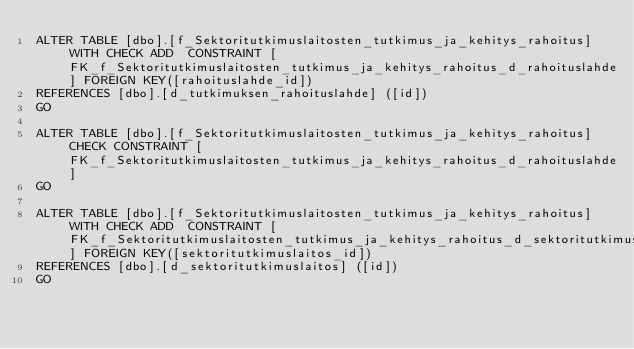Convert code to text. <code><loc_0><loc_0><loc_500><loc_500><_SQL_>ALTER TABLE [dbo].[f_Sektoritutkimuslaitosten_tutkimus_ja_kehitys_rahoitus]  WITH CHECK ADD  CONSTRAINT [FK_f_Sektoritutkimuslaitosten_tutkimus_ja_kehitys_rahoitus_d_rahoituslahde] FOREIGN KEY([rahoituslahde_id])
REFERENCES [dbo].[d_tutkimuksen_rahoituslahde] ([id])
GO

ALTER TABLE [dbo].[f_Sektoritutkimuslaitosten_tutkimus_ja_kehitys_rahoitus] CHECK CONSTRAINT [FK_f_Sektoritutkimuslaitosten_tutkimus_ja_kehitys_rahoitus_d_rahoituslahde]
GO

ALTER TABLE [dbo].[f_Sektoritutkimuslaitosten_tutkimus_ja_kehitys_rahoitus]  WITH CHECK ADD  CONSTRAINT [FK_f_Sektoritutkimuslaitosten_tutkimus_ja_kehitys_rahoitus_d_sektoritutkimuslaitos] FOREIGN KEY([sektoritutkimuslaitos_id])
REFERENCES [dbo].[d_sektoritutkimuslaitos] ([id])
GO
</code> 